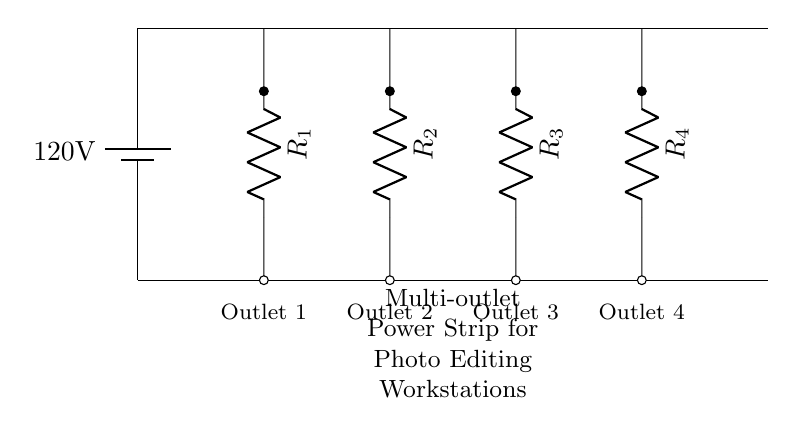What is the supply voltage for this power strip? The power strip is connected to a battery that provides a voltage of 120 volts. This is indicated at the top of the circuit diagram.
Answer: 120 volts How many outlets are there in this power strip? The circuit diagram shows a total of four outlets, as defined by four resistors labeled R1, R2, R3, and R4. Each outlet corresponds to one resistor in the diagram.
Answer: Four What type of circuit is represented in this diagram? The layout of the outlets (resistors) in the diagram indicates a parallel circuit configuration, where each outlet is connected across the same voltage supply.
Answer: Parallel What is the function of the resistors in this circuit? In this setup, the resistors represent the loads that each outlet supplies power to. They simulate the electrical devices that may be plugged into each outlet and draw current from the power strip.
Answer: Loads How does current flow in this parallel circuit? In a parallel circuit, the current flows through multiple paths. Each outlet allows current to flow independently from the others, which means each resistor experiences the full supply voltage of 120 volts.
Answer: Independently 